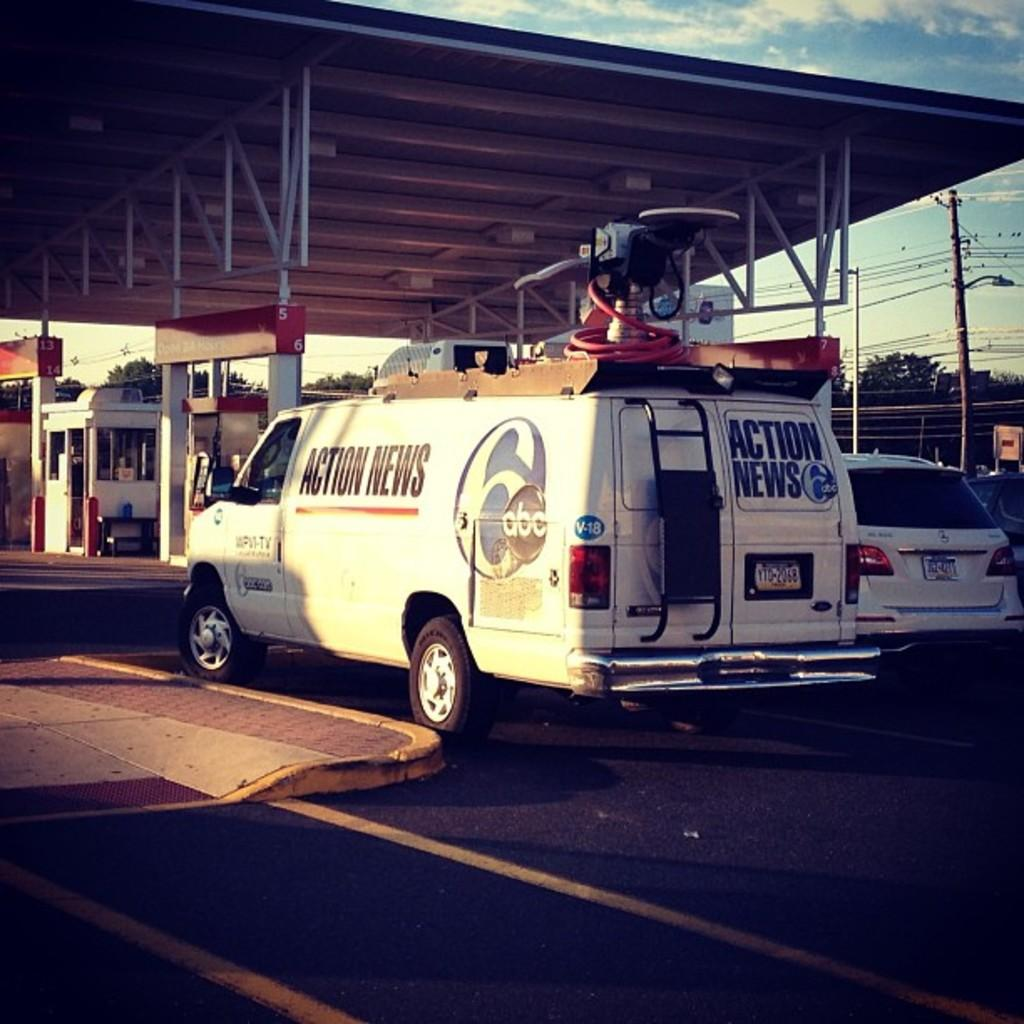Provide a one-sentence caption for the provided image. A news truck is parked outside of a gas station. 